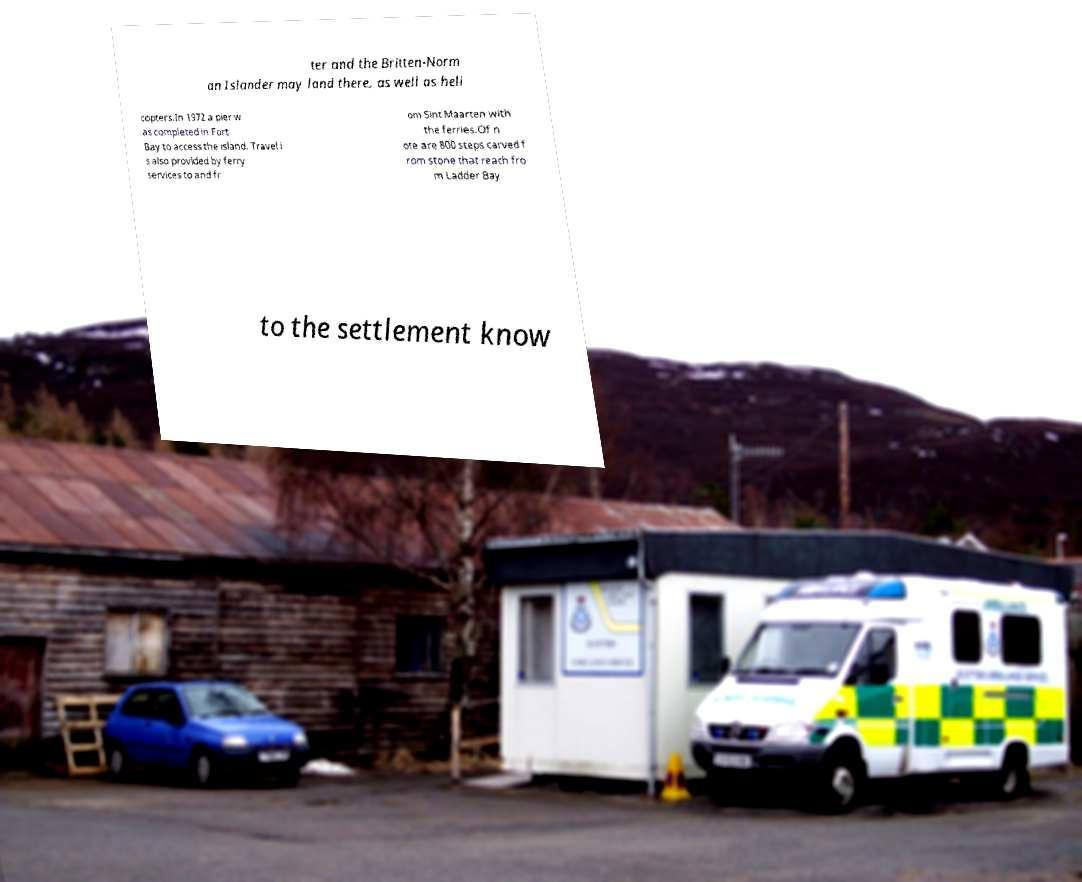Could you extract and type out the text from this image? ter and the Britten-Norm an Islander may land there, as well as heli copters.In 1972 a pier w as completed in Fort Bay to access the island. Travel i s also provided by ferry services to and fr om Sint Maarten with the ferries.Of n ote are 800 steps carved f rom stone that reach fro m Ladder Bay to the settlement know 